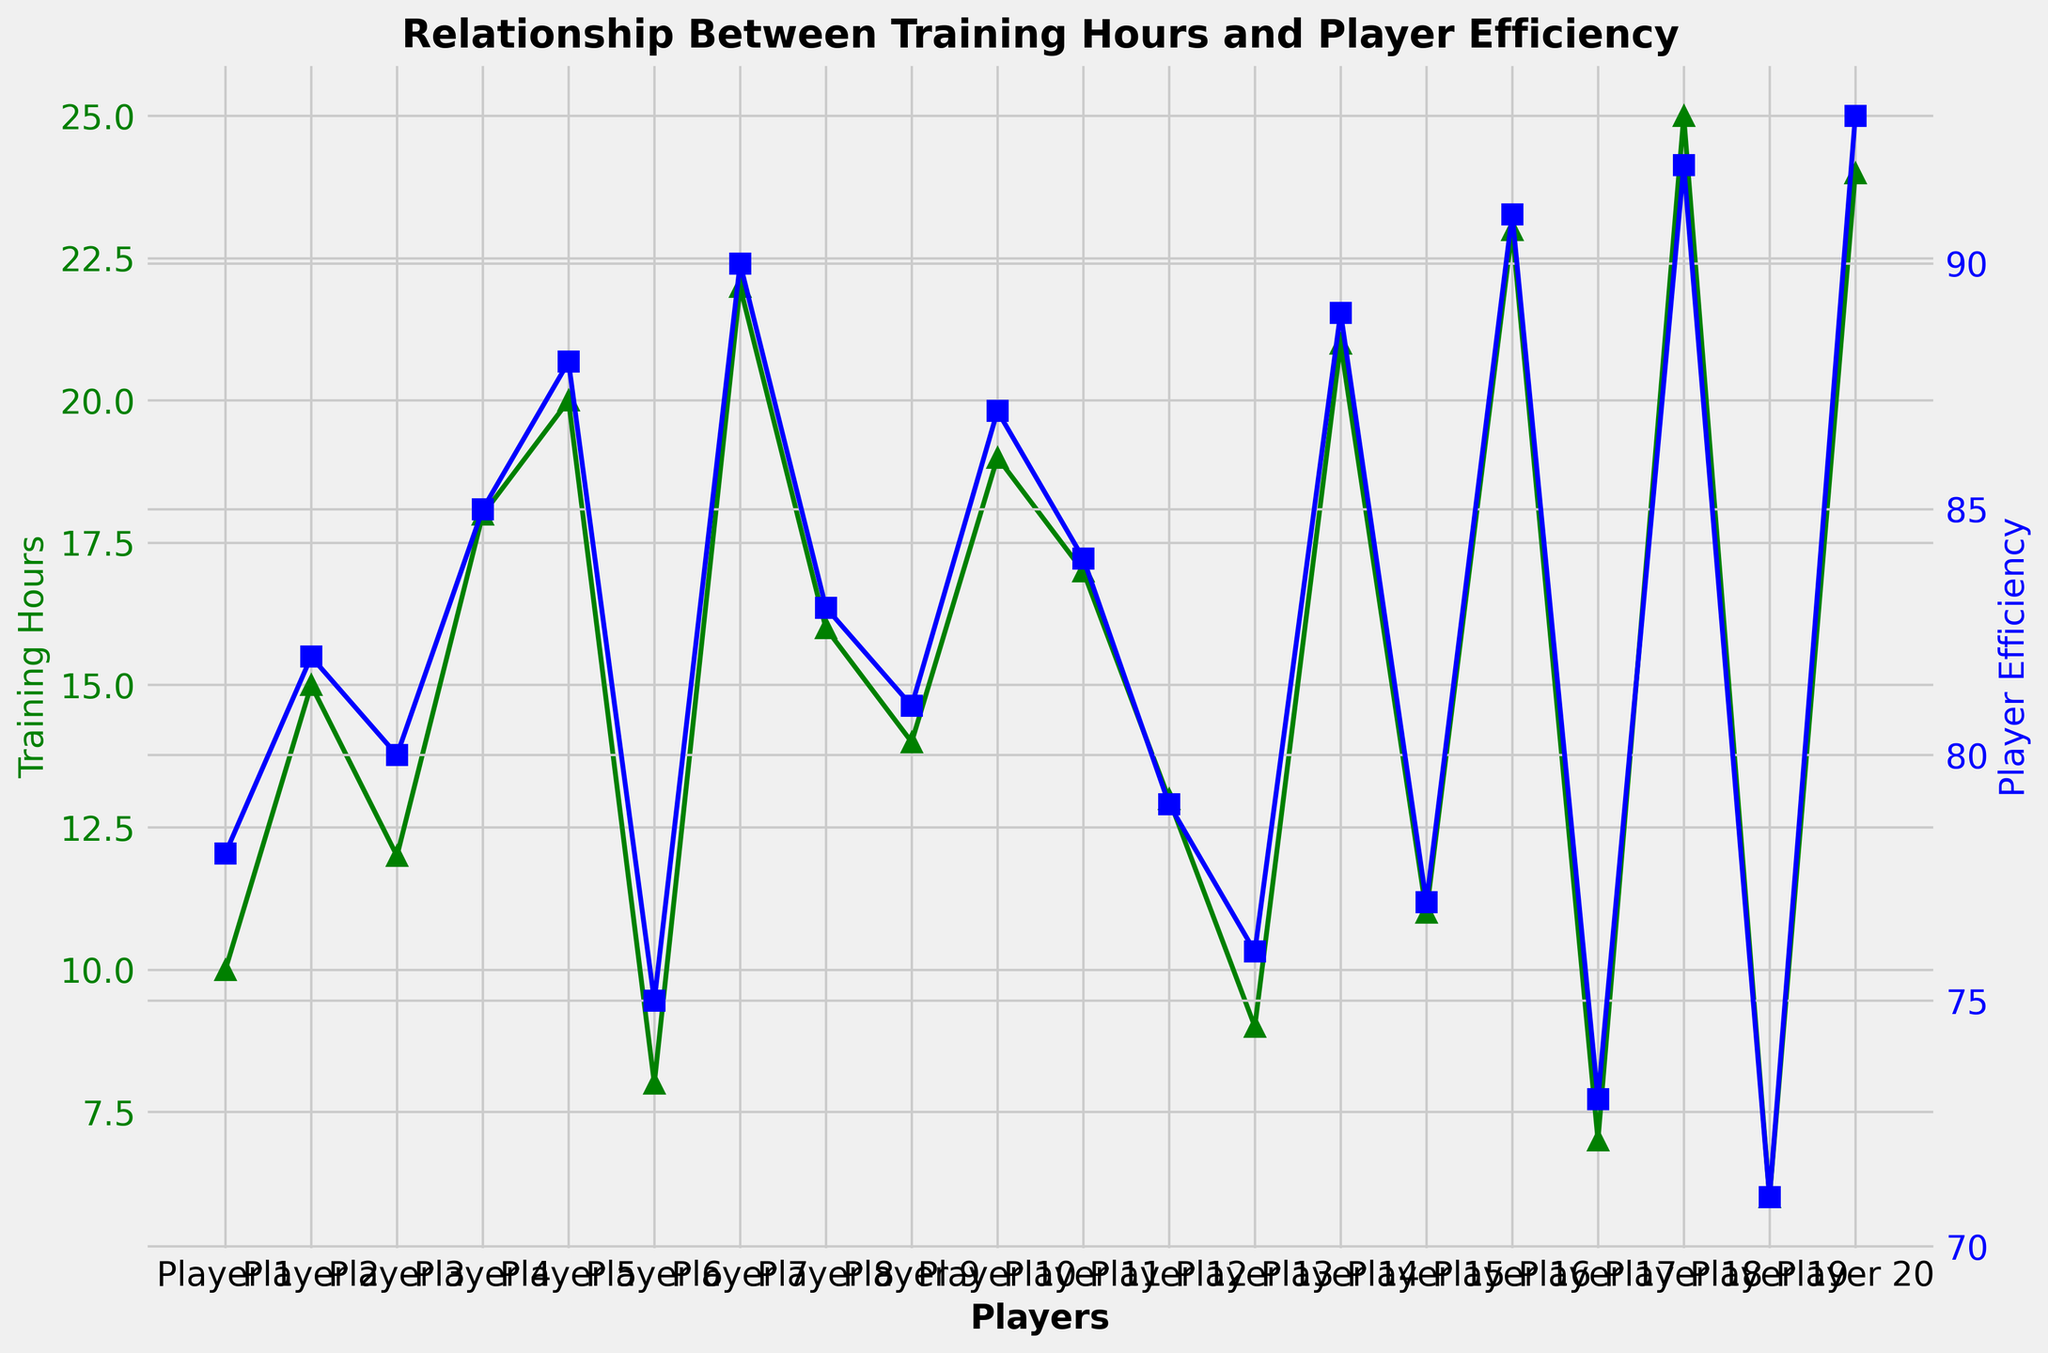What’s the average training hours across all players? To find the average training hours, add up the training hours for all players and then divide by the number of players. Sum of training hours: 10 + 15 + 12 + 18 + 20 + 8 + 22 + 16 + 14 + 19 + 17 + 13 + 9 + 21 + 11 + 23 + 7 + 25 + 6 + 24 = 310. There are 20 players, so the average is 310 / 20 = 15.5.
Answer: 15.5 Which player has the highest player efficiency? To determine the highest player efficiency, look for the highest point on the blue line representing player efficiency. The highest point at 93 is for Player 20.
Answer: Player 20 Is there a player who worked fewer than 10 hours of training but has a player efficiency above 75? Look for points where the training hours (green line) are below 10 and cross-check with player efficiency (blue line) above 75. Player 6 trained for 8 hours and has an efficiency of 75, which is not above 75. Player 13 trained for 9 hours with an efficiency of 76, which fits the criteria.
Answer: Yes, Player 13 What is the difference in player efficiency between the player with the most training hours and the player with the least training hours? The player with the most training hours is Player 18 with 25 hours and an efficiency of 92. The player with the least training hours is Player 19 with 6 hours and an efficiency of 71. The difference is 92 - 71 = 21.
Answer: 21 How many players have a training time above the average training hours but player efficiency below 85? The average training hours are 15.5. Look for players with training hours above 15.5 and efficiency below 85: Player 8, Player 9, and Player 11 fit the criteria.
Answer: 3 Which player shows the least improvement in efficiency despite a considerable amount of training hours? Look for players with higher training hours but relatively low efficiencies. Player 15 trained for 11 hours with an efficiency of 77, but Player 7 trained for 22 hours with an efficiency of 90, leading to a high efficiency. Comparing relatively low efficiency with considerable training, Player 15 fits better.
Answer: Player 15 